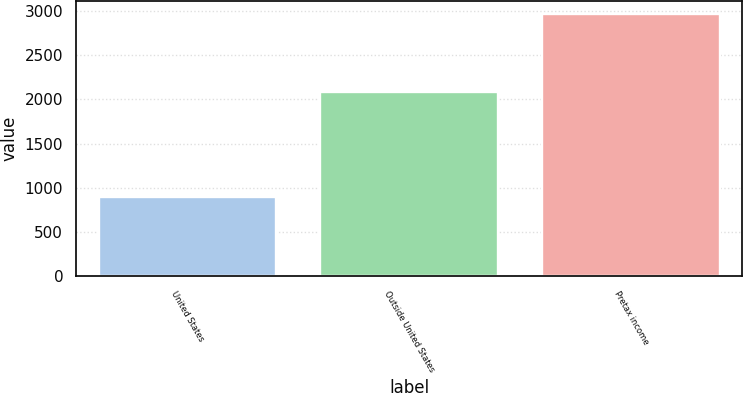Convert chart to OTSL. <chart><loc_0><loc_0><loc_500><loc_500><bar_chart><fcel>United States<fcel>Outside United States<fcel>Pretax income<nl><fcel>892<fcel>2080<fcel>2972<nl></chart> 